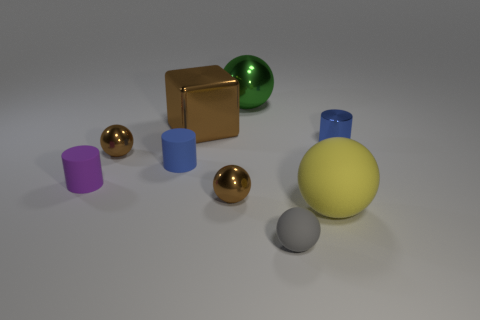Is the shape of the blue matte object the same as the tiny rubber thing that is in front of the yellow sphere?
Make the answer very short. No. Is there any other thing that is the same color as the large metal ball?
Offer a very short reply. No. Does the small matte cylinder in front of the blue rubber object have the same color as the shiny cube that is in front of the large metallic sphere?
Your answer should be compact. No. Is there a small shiny cylinder?
Offer a very short reply. Yes. Are there any balls that have the same material as the big green thing?
Give a very brief answer. Yes. Is there any other thing that is the same material as the purple cylinder?
Offer a very short reply. Yes. The large block has what color?
Ensure brevity in your answer.  Brown. The thing that is the same color as the tiny metallic cylinder is what shape?
Your response must be concise. Cylinder. The metallic cube that is the same size as the yellow ball is what color?
Provide a succinct answer. Brown. What number of rubber things are either small cylinders or small brown cylinders?
Ensure brevity in your answer.  2. 